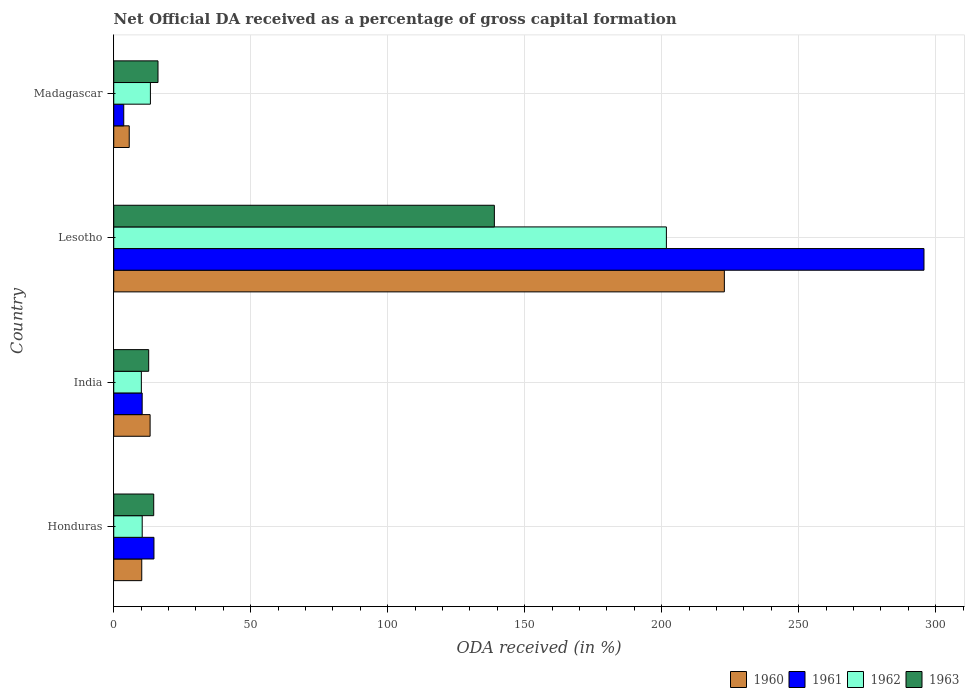How many different coloured bars are there?
Keep it short and to the point. 4. Are the number of bars on each tick of the Y-axis equal?
Your answer should be very brief. Yes. What is the label of the 1st group of bars from the top?
Offer a terse response. Madagascar. In how many cases, is the number of bars for a given country not equal to the number of legend labels?
Your response must be concise. 0. What is the net ODA received in 1960 in Honduras?
Your response must be concise. 10.23. Across all countries, what is the maximum net ODA received in 1960?
Offer a terse response. 222.86. Across all countries, what is the minimum net ODA received in 1961?
Your answer should be compact. 3.65. In which country was the net ODA received in 1962 maximum?
Your response must be concise. Lesotho. In which country was the net ODA received in 1961 minimum?
Provide a succinct answer. Madagascar. What is the total net ODA received in 1960 in the graph?
Your response must be concise. 252.01. What is the difference between the net ODA received in 1962 in India and that in Lesotho?
Provide a succinct answer. -191.62. What is the difference between the net ODA received in 1962 in Lesotho and the net ODA received in 1963 in Madagascar?
Your answer should be compact. 185.55. What is the average net ODA received in 1962 per country?
Ensure brevity in your answer.  58.89. What is the difference between the net ODA received in 1960 and net ODA received in 1962 in India?
Provide a short and direct response. 3.19. In how many countries, is the net ODA received in 1960 greater than 200 %?
Provide a short and direct response. 1. What is the ratio of the net ODA received in 1962 in Honduras to that in India?
Your response must be concise. 1.03. Is the difference between the net ODA received in 1960 in Honduras and Madagascar greater than the difference between the net ODA received in 1962 in Honduras and Madagascar?
Your response must be concise. Yes. What is the difference between the highest and the second highest net ODA received in 1961?
Your response must be concise. 281.04. What is the difference between the highest and the lowest net ODA received in 1962?
Give a very brief answer. 191.62. Is the sum of the net ODA received in 1963 in Honduras and Lesotho greater than the maximum net ODA received in 1960 across all countries?
Provide a short and direct response. No. Is it the case that in every country, the sum of the net ODA received in 1963 and net ODA received in 1962 is greater than the sum of net ODA received in 1960 and net ODA received in 1961?
Your answer should be compact. No. What does the 2nd bar from the top in Lesotho represents?
Offer a very short reply. 1962. Is it the case that in every country, the sum of the net ODA received in 1960 and net ODA received in 1963 is greater than the net ODA received in 1962?
Offer a very short reply. Yes. Are all the bars in the graph horizontal?
Provide a succinct answer. Yes. Does the graph contain any zero values?
Offer a very short reply. No. Does the graph contain grids?
Make the answer very short. Yes. How many legend labels are there?
Your answer should be compact. 4. What is the title of the graph?
Your response must be concise. Net Official DA received as a percentage of gross capital formation. What is the label or title of the X-axis?
Your response must be concise. ODA received (in %). What is the label or title of the Y-axis?
Make the answer very short. Country. What is the ODA received (in %) of 1960 in Honduras?
Keep it short and to the point. 10.23. What is the ODA received (in %) in 1961 in Honduras?
Offer a terse response. 14.68. What is the ODA received (in %) of 1962 in Honduras?
Your response must be concise. 10.39. What is the ODA received (in %) in 1963 in Honduras?
Provide a succinct answer. 14.59. What is the ODA received (in %) of 1960 in India?
Your answer should be compact. 13.27. What is the ODA received (in %) of 1961 in India?
Give a very brief answer. 10.37. What is the ODA received (in %) of 1962 in India?
Your answer should be compact. 10.08. What is the ODA received (in %) in 1963 in India?
Offer a terse response. 12.76. What is the ODA received (in %) in 1960 in Lesotho?
Offer a very short reply. 222.86. What is the ODA received (in %) of 1961 in Lesotho?
Your answer should be compact. 295.71. What is the ODA received (in %) in 1962 in Lesotho?
Offer a terse response. 201.7. What is the ODA received (in %) in 1963 in Lesotho?
Ensure brevity in your answer.  138.92. What is the ODA received (in %) in 1960 in Madagascar?
Provide a succinct answer. 5.66. What is the ODA received (in %) in 1961 in Madagascar?
Keep it short and to the point. 3.65. What is the ODA received (in %) in 1962 in Madagascar?
Keep it short and to the point. 13.38. What is the ODA received (in %) in 1963 in Madagascar?
Ensure brevity in your answer.  16.15. Across all countries, what is the maximum ODA received (in %) in 1960?
Give a very brief answer. 222.86. Across all countries, what is the maximum ODA received (in %) of 1961?
Your response must be concise. 295.71. Across all countries, what is the maximum ODA received (in %) in 1962?
Provide a short and direct response. 201.7. Across all countries, what is the maximum ODA received (in %) of 1963?
Ensure brevity in your answer.  138.92. Across all countries, what is the minimum ODA received (in %) in 1960?
Offer a terse response. 5.66. Across all countries, what is the minimum ODA received (in %) in 1961?
Your response must be concise. 3.65. Across all countries, what is the minimum ODA received (in %) of 1962?
Keep it short and to the point. 10.08. Across all countries, what is the minimum ODA received (in %) in 1963?
Offer a terse response. 12.76. What is the total ODA received (in %) of 1960 in the graph?
Give a very brief answer. 252.01. What is the total ODA received (in %) in 1961 in the graph?
Your answer should be very brief. 324.42. What is the total ODA received (in %) of 1962 in the graph?
Offer a terse response. 235.55. What is the total ODA received (in %) in 1963 in the graph?
Your answer should be compact. 182.42. What is the difference between the ODA received (in %) in 1960 in Honduras and that in India?
Your answer should be very brief. -3.05. What is the difference between the ODA received (in %) in 1961 in Honduras and that in India?
Make the answer very short. 4.3. What is the difference between the ODA received (in %) of 1962 in Honduras and that in India?
Offer a very short reply. 0.31. What is the difference between the ODA received (in %) of 1963 in Honduras and that in India?
Provide a succinct answer. 1.84. What is the difference between the ODA received (in %) of 1960 in Honduras and that in Lesotho?
Ensure brevity in your answer.  -212.63. What is the difference between the ODA received (in %) in 1961 in Honduras and that in Lesotho?
Keep it short and to the point. -281.04. What is the difference between the ODA received (in %) of 1962 in Honduras and that in Lesotho?
Offer a terse response. -191.31. What is the difference between the ODA received (in %) of 1963 in Honduras and that in Lesotho?
Your answer should be compact. -124.33. What is the difference between the ODA received (in %) in 1960 in Honduras and that in Madagascar?
Your response must be concise. 4.57. What is the difference between the ODA received (in %) of 1961 in Honduras and that in Madagascar?
Your answer should be compact. 11.03. What is the difference between the ODA received (in %) in 1962 in Honduras and that in Madagascar?
Keep it short and to the point. -2.99. What is the difference between the ODA received (in %) of 1963 in Honduras and that in Madagascar?
Your answer should be very brief. -1.56. What is the difference between the ODA received (in %) in 1960 in India and that in Lesotho?
Offer a very short reply. -209.59. What is the difference between the ODA received (in %) in 1961 in India and that in Lesotho?
Ensure brevity in your answer.  -285.34. What is the difference between the ODA received (in %) in 1962 in India and that in Lesotho?
Provide a succinct answer. -191.62. What is the difference between the ODA received (in %) of 1963 in India and that in Lesotho?
Keep it short and to the point. -126.16. What is the difference between the ODA received (in %) in 1960 in India and that in Madagascar?
Provide a short and direct response. 7.62. What is the difference between the ODA received (in %) of 1961 in India and that in Madagascar?
Offer a very short reply. 6.72. What is the difference between the ODA received (in %) in 1963 in India and that in Madagascar?
Ensure brevity in your answer.  -3.4. What is the difference between the ODA received (in %) in 1960 in Lesotho and that in Madagascar?
Provide a short and direct response. 217.2. What is the difference between the ODA received (in %) of 1961 in Lesotho and that in Madagascar?
Make the answer very short. 292.06. What is the difference between the ODA received (in %) in 1962 in Lesotho and that in Madagascar?
Provide a short and direct response. 188.32. What is the difference between the ODA received (in %) of 1963 in Lesotho and that in Madagascar?
Provide a short and direct response. 122.76. What is the difference between the ODA received (in %) of 1960 in Honduras and the ODA received (in %) of 1961 in India?
Provide a succinct answer. -0.15. What is the difference between the ODA received (in %) of 1960 in Honduras and the ODA received (in %) of 1962 in India?
Provide a short and direct response. 0.14. What is the difference between the ODA received (in %) of 1960 in Honduras and the ODA received (in %) of 1963 in India?
Provide a succinct answer. -2.53. What is the difference between the ODA received (in %) in 1961 in Honduras and the ODA received (in %) in 1962 in India?
Give a very brief answer. 4.6. What is the difference between the ODA received (in %) of 1961 in Honduras and the ODA received (in %) of 1963 in India?
Make the answer very short. 1.92. What is the difference between the ODA received (in %) of 1962 in Honduras and the ODA received (in %) of 1963 in India?
Make the answer very short. -2.37. What is the difference between the ODA received (in %) in 1960 in Honduras and the ODA received (in %) in 1961 in Lesotho?
Offer a terse response. -285.49. What is the difference between the ODA received (in %) in 1960 in Honduras and the ODA received (in %) in 1962 in Lesotho?
Your answer should be very brief. -191.48. What is the difference between the ODA received (in %) of 1960 in Honduras and the ODA received (in %) of 1963 in Lesotho?
Provide a succinct answer. -128.69. What is the difference between the ODA received (in %) in 1961 in Honduras and the ODA received (in %) in 1962 in Lesotho?
Offer a very short reply. -187.02. What is the difference between the ODA received (in %) of 1961 in Honduras and the ODA received (in %) of 1963 in Lesotho?
Keep it short and to the point. -124.24. What is the difference between the ODA received (in %) in 1962 in Honduras and the ODA received (in %) in 1963 in Lesotho?
Make the answer very short. -128.53. What is the difference between the ODA received (in %) in 1960 in Honduras and the ODA received (in %) in 1961 in Madagascar?
Your response must be concise. 6.57. What is the difference between the ODA received (in %) of 1960 in Honduras and the ODA received (in %) of 1962 in Madagascar?
Offer a terse response. -3.16. What is the difference between the ODA received (in %) in 1960 in Honduras and the ODA received (in %) in 1963 in Madagascar?
Offer a terse response. -5.93. What is the difference between the ODA received (in %) in 1961 in Honduras and the ODA received (in %) in 1962 in Madagascar?
Give a very brief answer. 1.3. What is the difference between the ODA received (in %) of 1961 in Honduras and the ODA received (in %) of 1963 in Madagascar?
Offer a terse response. -1.48. What is the difference between the ODA received (in %) in 1962 in Honduras and the ODA received (in %) in 1963 in Madagascar?
Your response must be concise. -5.76. What is the difference between the ODA received (in %) of 1960 in India and the ODA received (in %) of 1961 in Lesotho?
Offer a very short reply. -282.44. What is the difference between the ODA received (in %) in 1960 in India and the ODA received (in %) in 1962 in Lesotho?
Your answer should be very brief. -188.43. What is the difference between the ODA received (in %) in 1960 in India and the ODA received (in %) in 1963 in Lesotho?
Provide a short and direct response. -125.65. What is the difference between the ODA received (in %) in 1961 in India and the ODA received (in %) in 1962 in Lesotho?
Offer a terse response. -191.33. What is the difference between the ODA received (in %) of 1961 in India and the ODA received (in %) of 1963 in Lesotho?
Offer a very short reply. -128.54. What is the difference between the ODA received (in %) in 1962 in India and the ODA received (in %) in 1963 in Lesotho?
Your answer should be very brief. -128.84. What is the difference between the ODA received (in %) of 1960 in India and the ODA received (in %) of 1961 in Madagascar?
Your answer should be very brief. 9.62. What is the difference between the ODA received (in %) of 1960 in India and the ODA received (in %) of 1962 in Madagascar?
Your answer should be very brief. -0.11. What is the difference between the ODA received (in %) in 1960 in India and the ODA received (in %) in 1963 in Madagascar?
Ensure brevity in your answer.  -2.88. What is the difference between the ODA received (in %) of 1961 in India and the ODA received (in %) of 1962 in Madagascar?
Provide a succinct answer. -3.01. What is the difference between the ODA received (in %) in 1961 in India and the ODA received (in %) in 1963 in Madagascar?
Offer a very short reply. -5.78. What is the difference between the ODA received (in %) in 1962 in India and the ODA received (in %) in 1963 in Madagascar?
Give a very brief answer. -6.07. What is the difference between the ODA received (in %) of 1960 in Lesotho and the ODA received (in %) of 1961 in Madagascar?
Your answer should be compact. 219.21. What is the difference between the ODA received (in %) of 1960 in Lesotho and the ODA received (in %) of 1962 in Madagascar?
Your response must be concise. 209.48. What is the difference between the ODA received (in %) in 1960 in Lesotho and the ODA received (in %) in 1963 in Madagascar?
Provide a succinct answer. 206.7. What is the difference between the ODA received (in %) of 1961 in Lesotho and the ODA received (in %) of 1962 in Madagascar?
Offer a terse response. 282.33. What is the difference between the ODA received (in %) in 1961 in Lesotho and the ODA received (in %) in 1963 in Madagascar?
Your response must be concise. 279.56. What is the difference between the ODA received (in %) in 1962 in Lesotho and the ODA received (in %) in 1963 in Madagascar?
Make the answer very short. 185.55. What is the average ODA received (in %) of 1960 per country?
Offer a terse response. 63. What is the average ODA received (in %) in 1961 per country?
Ensure brevity in your answer.  81.1. What is the average ODA received (in %) of 1962 per country?
Make the answer very short. 58.89. What is the average ODA received (in %) of 1963 per country?
Offer a terse response. 45.6. What is the difference between the ODA received (in %) of 1960 and ODA received (in %) of 1961 in Honduras?
Offer a terse response. -4.45. What is the difference between the ODA received (in %) of 1960 and ODA received (in %) of 1962 in Honduras?
Offer a very short reply. -0.16. What is the difference between the ODA received (in %) in 1960 and ODA received (in %) in 1963 in Honduras?
Your response must be concise. -4.37. What is the difference between the ODA received (in %) of 1961 and ODA received (in %) of 1962 in Honduras?
Your response must be concise. 4.29. What is the difference between the ODA received (in %) in 1961 and ODA received (in %) in 1963 in Honduras?
Your answer should be very brief. 0.09. What is the difference between the ODA received (in %) in 1962 and ODA received (in %) in 1963 in Honduras?
Provide a short and direct response. -4.2. What is the difference between the ODA received (in %) in 1960 and ODA received (in %) in 1961 in India?
Give a very brief answer. 2.9. What is the difference between the ODA received (in %) in 1960 and ODA received (in %) in 1962 in India?
Your response must be concise. 3.19. What is the difference between the ODA received (in %) in 1960 and ODA received (in %) in 1963 in India?
Make the answer very short. 0.52. What is the difference between the ODA received (in %) of 1961 and ODA received (in %) of 1962 in India?
Ensure brevity in your answer.  0.29. What is the difference between the ODA received (in %) in 1961 and ODA received (in %) in 1963 in India?
Provide a succinct answer. -2.38. What is the difference between the ODA received (in %) of 1962 and ODA received (in %) of 1963 in India?
Make the answer very short. -2.68. What is the difference between the ODA received (in %) of 1960 and ODA received (in %) of 1961 in Lesotho?
Provide a short and direct response. -72.86. What is the difference between the ODA received (in %) in 1960 and ODA received (in %) in 1962 in Lesotho?
Your answer should be very brief. 21.16. What is the difference between the ODA received (in %) of 1960 and ODA received (in %) of 1963 in Lesotho?
Offer a terse response. 83.94. What is the difference between the ODA received (in %) of 1961 and ODA received (in %) of 1962 in Lesotho?
Offer a very short reply. 94.01. What is the difference between the ODA received (in %) of 1961 and ODA received (in %) of 1963 in Lesotho?
Provide a short and direct response. 156.8. What is the difference between the ODA received (in %) of 1962 and ODA received (in %) of 1963 in Lesotho?
Your response must be concise. 62.78. What is the difference between the ODA received (in %) in 1960 and ODA received (in %) in 1961 in Madagascar?
Give a very brief answer. 2. What is the difference between the ODA received (in %) of 1960 and ODA received (in %) of 1962 in Madagascar?
Your answer should be compact. -7.72. What is the difference between the ODA received (in %) of 1960 and ODA received (in %) of 1963 in Madagascar?
Offer a very short reply. -10.5. What is the difference between the ODA received (in %) in 1961 and ODA received (in %) in 1962 in Madagascar?
Provide a succinct answer. -9.73. What is the difference between the ODA received (in %) in 1961 and ODA received (in %) in 1963 in Madagascar?
Make the answer very short. -12.5. What is the difference between the ODA received (in %) of 1962 and ODA received (in %) of 1963 in Madagascar?
Make the answer very short. -2.77. What is the ratio of the ODA received (in %) of 1960 in Honduras to that in India?
Offer a very short reply. 0.77. What is the ratio of the ODA received (in %) of 1961 in Honduras to that in India?
Provide a succinct answer. 1.41. What is the ratio of the ODA received (in %) in 1962 in Honduras to that in India?
Make the answer very short. 1.03. What is the ratio of the ODA received (in %) in 1963 in Honduras to that in India?
Ensure brevity in your answer.  1.14. What is the ratio of the ODA received (in %) in 1960 in Honduras to that in Lesotho?
Your answer should be compact. 0.05. What is the ratio of the ODA received (in %) in 1961 in Honduras to that in Lesotho?
Make the answer very short. 0.05. What is the ratio of the ODA received (in %) of 1962 in Honduras to that in Lesotho?
Offer a very short reply. 0.05. What is the ratio of the ODA received (in %) in 1963 in Honduras to that in Lesotho?
Make the answer very short. 0.1. What is the ratio of the ODA received (in %) in 1960 in Honduras to that in Madagascar?
Ensure brevity in your answer.  1.81. What is the ratio of the ODA received (in %) in 1961 in Honduras to that in Madagascar?
Ensure brevity in your answer.  4.02. What is the ratio of the ODA received (in %) of 1962 in Honduras to that in Madagascar?
Give a very brief answer. 0.78. What is the ratio of the ODA received (in %) in 1963 in Honduras to that in Madagascar?
Make the answer very short. 0.9. What is the ratio of the ODA received (in %) of 1960 in India to that in Lesotho?
Your answer should be very brief. 0.06. What is the ratio of the ODA received (in %) of 1961 in India to that in Lesotho?
Keep it short and to the point. 0.04. What is the ratio of the ODA received (in %) of 1963 in India to that in Lesotho?
Provide a short and direct response. 0.09. What is the ratio of the ODA received (in %) in 1960 in India to that in Madagascar?
Provide a short and direct response. 2.35. What is the ratio of the ODA received (in %) in 1961 in India to that in Madagascar?
Your answer should be very brief. 2.84. What is the ratio of the ODA received (in %) in 1962 in India to that in Madagascar?
Give a very brief answer. 0.75. What is the ratio of the ODA received (in %) of 1963 in India to that in Madagascar?
Offer a very short reply. 0.79. What is the ratio of the ODA received (in %) of 1960 in Lesotho to that in Madagascar?
Offer a very short reply. 39.4. What is the ratio of the ODA received (in %) of 1961 in Lesotho to that in Madagascar?
Your answer should be compact. 80.97. What is the ratio of the ODA received (in %) in 1962 in Lesotho to that in Madagascar?
Your response must be concise. 15.07. What is the ratio of the ODA received (in %) in 1963 in Lesotho to that in Madagascar?
Your answer should be very brief. 8.6. What is the difference between the highest and the second highest ODA received (in %) in 1960?
Give a very brief answer. 209.59. What is the difference between the highest and the second highest ODA received (in %) of 1961?
Offer a terse response. 281.04. What is the difference between the highest and the second highest ODA received (in %) of 1962?
Provide a succinct answer. 188.32. What is the difference between the highest and the second highest ODA received (in %) in 1963?
Offer a terse response. 122.76. What is the difference between the highest and the lowest ODA received (in %) of 1960?
Offer a very short reply. 217.2. What is the difference between the highest and the lowest ODA received (in %) of 1961?
Make the answer very short. 292.06. What is the difference between the highest and the lowest ODA received (in %) of 1962?
Offer a very short reply. 191.62. What is the difference between the highest and the lowest ODA received (in %) of 1963?
Your response must be concise. 126.16. 